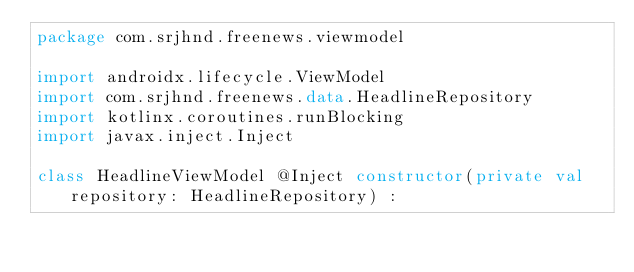<code> <loc_0><loc_0><loc_500><loc_500><_Kotlin_>package com.srjhnd.freenews.viewmodel

import androidx.lifecycle.ViewModel
import com.srjhnd.freenews.data.HeadlineRepository
import kotlinx.coroutines.runBlocking
import javax.inject.Inject

class HeadlineViewModel @Inject constructor(private val repository: HeadlineRepository) :</code> 